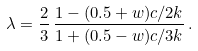<formula> <loc_0><loc_0><loc_500><loc_500>\lambda = \frac { 2 } { 3 } \, \frac { 1 - ( 0 . 5 + w ) c / 2 k } { 1 + ( 0 . 5 - w ) c / 3 k } \, .</formula> 